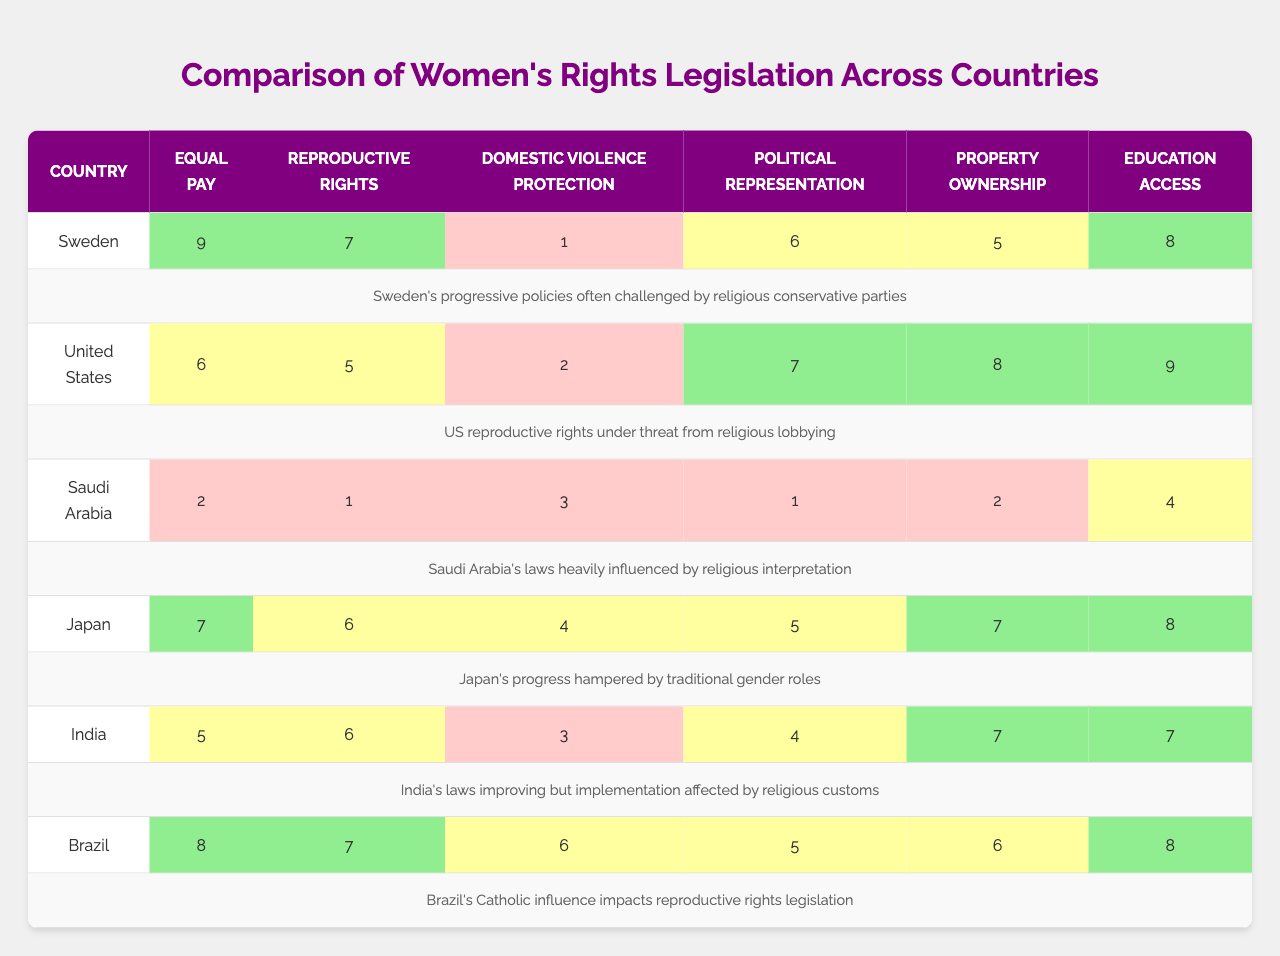What is the country with the highest score for political representation? Looking at the row for political representation, Sweden has a score of 6, the United States has 7, Saudi Arabia has 1, Japan has 5, India has 4, and Brazil has 5. The United States has the highest score of 7.
Answer: United States Which country scores the lowest in domestic violence protection? The scores for domestic violence protection are as follows: Sweden (1), United States (2), Saudi Arabia (3), Japan (4), India (3), Brazil (6). The lowest score is 1 from Sweden.
Answer: Sweden What is the average score for education access across all countries? The scores for education access are: Sweden (8), United States (9), Saudi Arabia (4), Japan (8), India (7), and Brazil (8). The sum of these scores is 8 + 9 + 4 + 8 + 7 + 8 = 44. There are 6 countries, so the average is 44 / 6 = 7.33.
Answer: 7.33 Which countries have a score of 7 or above in reproductive rights? The scores for reproductive rights are: Sweden (7), United States (5), Saudi Arabia (1), Japan (6), India (6), and Brazil (7). The countries with scores of 7 or above are Sweden, Brazil, and the United States.
Answer: Sweden, Brazil Is there a country where property ownership legislation is higher than in Saudi Arabia? The scores for property ownership are: Sweden (5), United States (8), Saudi Arabia (2), Japan (7), India (7), and Brazil (6). The countries with higher scores than Saudi Arabia (2) are Sweden, United States, Japan, India, and Brazil.
Answer: Yes What is the total score for women's rights legislation for India? The scores for India across all categories are: equal pay (5), reproductive rights (6), domestic violence protection (3), political representation (4), property ownership (7), and education access (7). The total score is 5 + 6 + 3 + 4 + 7 + 7 = 32.
Answer: 32 Which legislation category shows the greatest disparity between Sweden and Saudi Arabia? Comparing the scores for each category, the greatest difference is in equal pay, where Sweden scores 9 and Saudi Arabia scores 2, resulting in a disparity of 7.
Answer: Equal pay How many categories does Brazil score below 7? The scores for Brazil are: equal pay (8), reproductive rights (7), domestic violence protection (6), political representation (5), property ownership (6), and education access (8). Brazil scores below 7 in 3 categories: domestic violence protection, political representation, and property ownership.
Answer: 3 